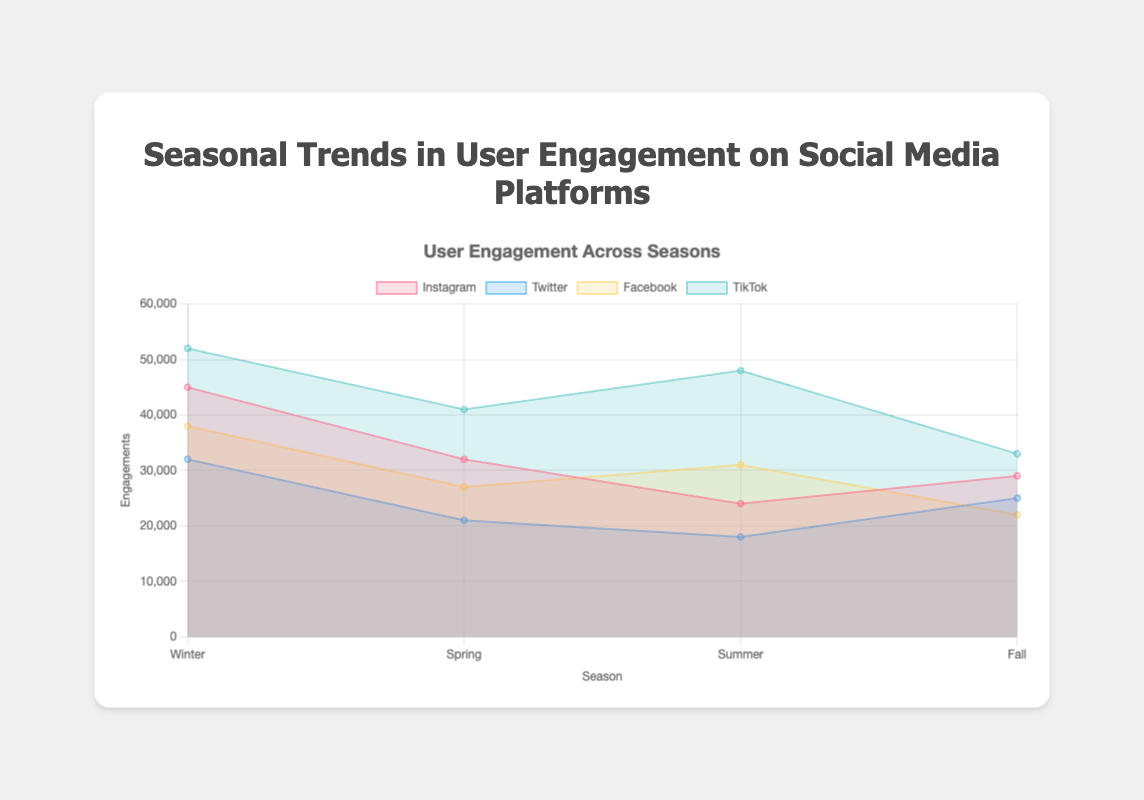What's the title of the chart? The title is prominently displayed at the top of the chart.
Answer: Seasonal Trends in User Engagement on Social Media Platforms Which season has the highest engagement on TikTok? Look at the peaks of each dataset and identify TikTok's highest value.
Answer: Winter What is the engagement difference between Instagram and Facebook in Summer? Subtract Instagram's engagement number from Facebook's engagement number in Summer.
Answer: 7000 Which platform has the lowest engagement in Fall? Identify the lowest point in the Fall section for all platforms.
Answer: Facebook What's the average engagement for Twitter across all seasons? Sum all Twitter engagements (32000 + 21000 + 18000 + 25000) and divide by the number of seasons (4).
Answer: 24000 Compare Winter engagement across all platforms. Which platform has the second highest engagement? List all Winter engagements and sort them to find the second highest.
Answer: Facebook During which season does Instagram have its lowest engagement? Look for the smallest value on Instagram across all seasons.
Answer: Summer How does Fall engagement on Instagram compare to Spring engagement on Twitter? Compare the numbers for Instagram in Fall (29000) and Twitter in Spring (21000).
Answer: Instagram has higher engagement Which two platforms have the closest engagement numbers in Winter? Compare all Winter numbers to find the two closest.
Answer: Facebook and Instagram What is the total engagement across all platforms in Summer? Sum all the engagements in Summer (24000 + 18000 + 31000 + 48000).
Answer: 121000 